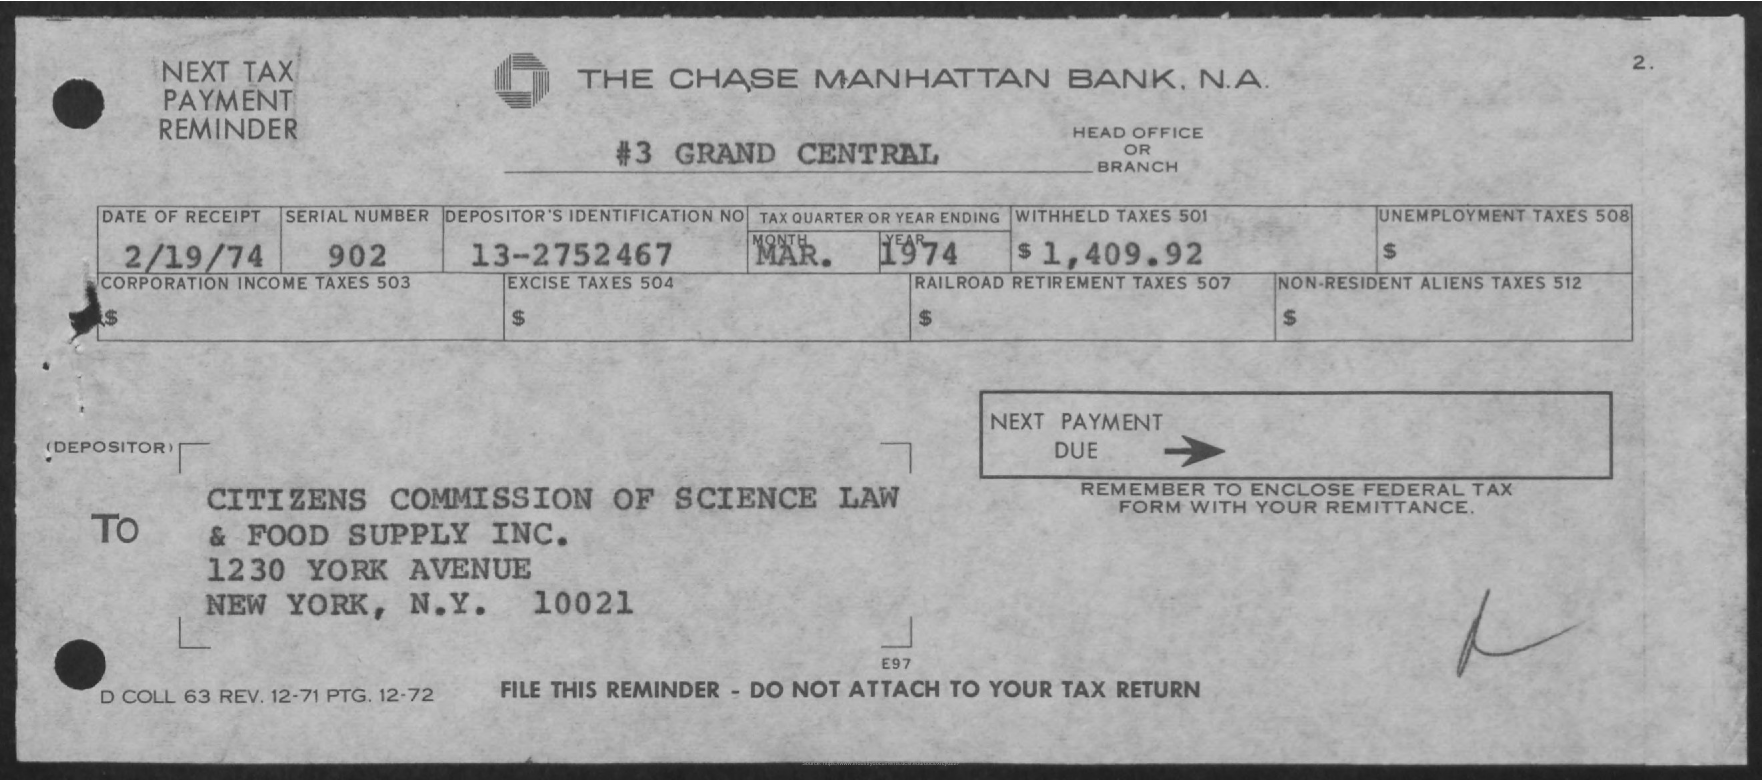Specify some key components in this picture. The city mentioned in the "To" address is New York. On what date was the item received? The date is February 19, 1974. The serial number is 902. The name of the bank is The Chase Manhattan Bank, N.A. The name of the head office or branch is Grand Central. 